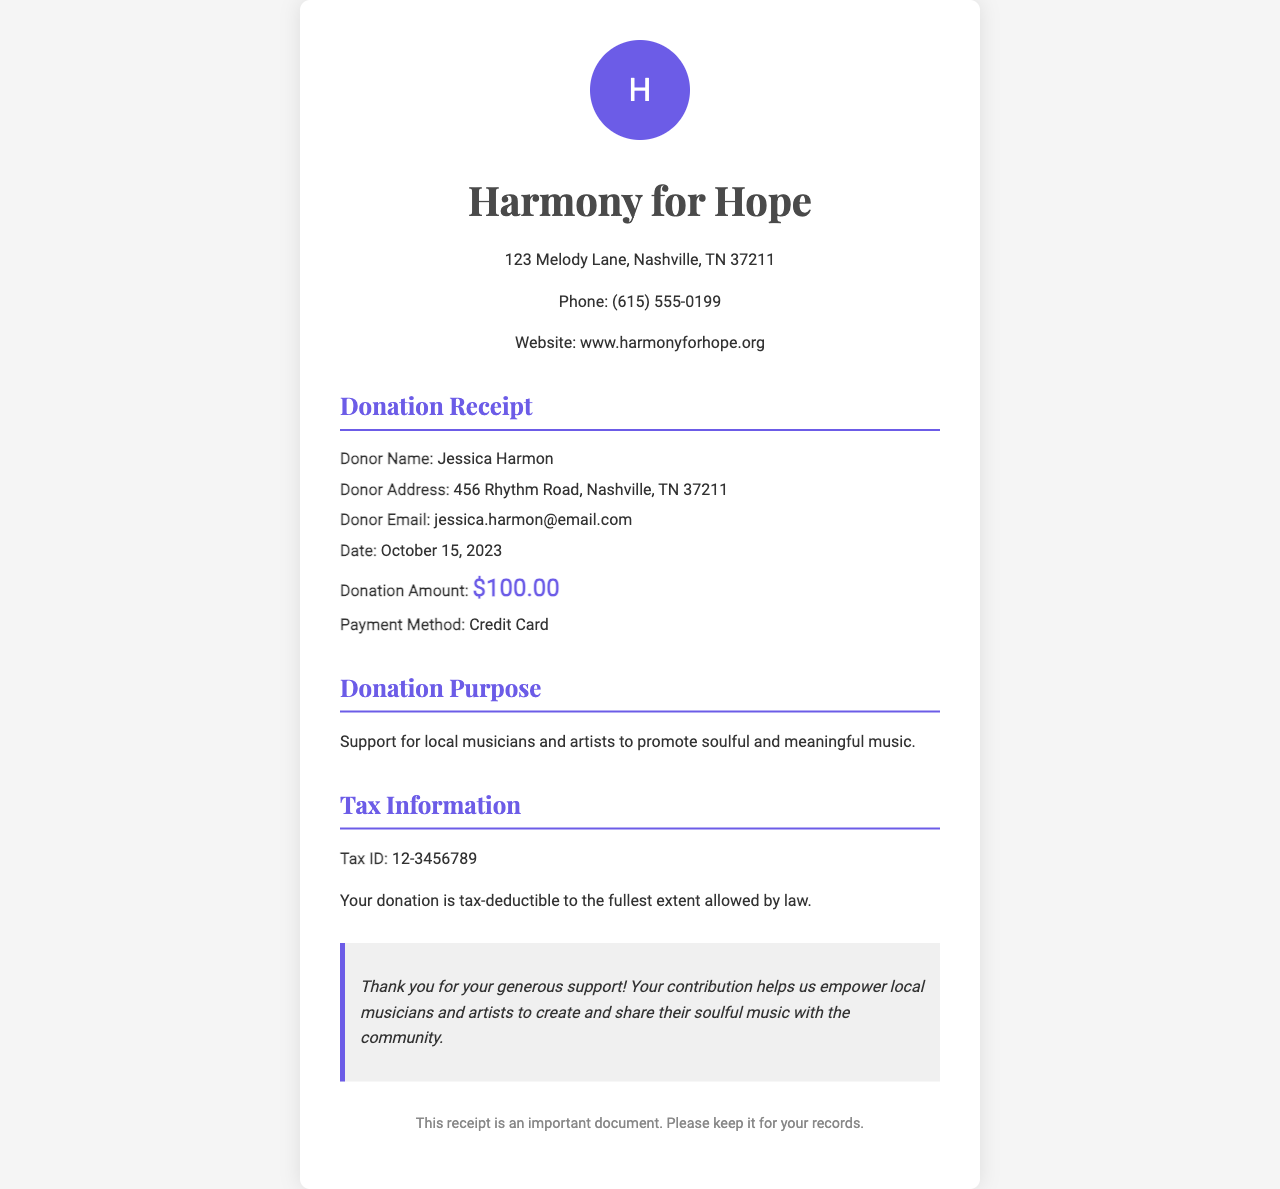what is the donor's name? The donor's name is specified in the details section of the receipt.
Answer: Jessica Harmon what is the donation amount? The donation amount is highlighted clearly in the document under the donation details.
Answer: $100.00 what date was the donation made? The date is provided in the details section of the receipt.
Answer: October 15, 2023 what tax ID is associated with this donation? The tax ID is included in the tax information section of the receipt.
Answer: 12-3456789 what is the purpose of the donation? The purpose of the donation is mentioned specifically in its own section of the receipt.
Answer: Support for local musicians and artists to promote soulful and meaningful music who is the organization receiving the donation? The organization's name is found in the header of the receipt.
Answer: Harmony for Hope what method was used for the payment? The payment method is indicated in the donation details section of the receipt.
Answer: Credit Card what type of document is this? The document title specifically identifies it as a donation receipt.
Answer: Donation Receipt what is mentioned about the tax deductibility of the donation? The tax information section mentions the deductibility of the donation.
Answer: Your donation is tax-deductible to the fullest extent allowed by law 